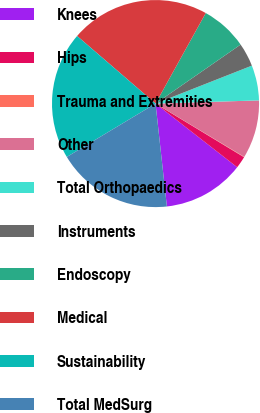Convert chart to OTSL. <chart><loc_0><loc_0><loc_500><loc_500><pie_chart><fcel>Knees<fcel>Hips<fcel>Trauma and Extremities<fcel>Other<fcel>Total Orthopaedics<fcel>Instruments<fcel>Endoscopy<fcel>Medical<fcel>Sustainability<fcel>Total MedSurg<nl><fcel>12.71%<fcel>1.87%<fcel>0.06%<fcel>9.1%<fcel>5.48%<fcel>3.68%<fcel>7.29%<fcel>21.74%<fcel>19.94%<fcel>18.13%<nl></chart> 